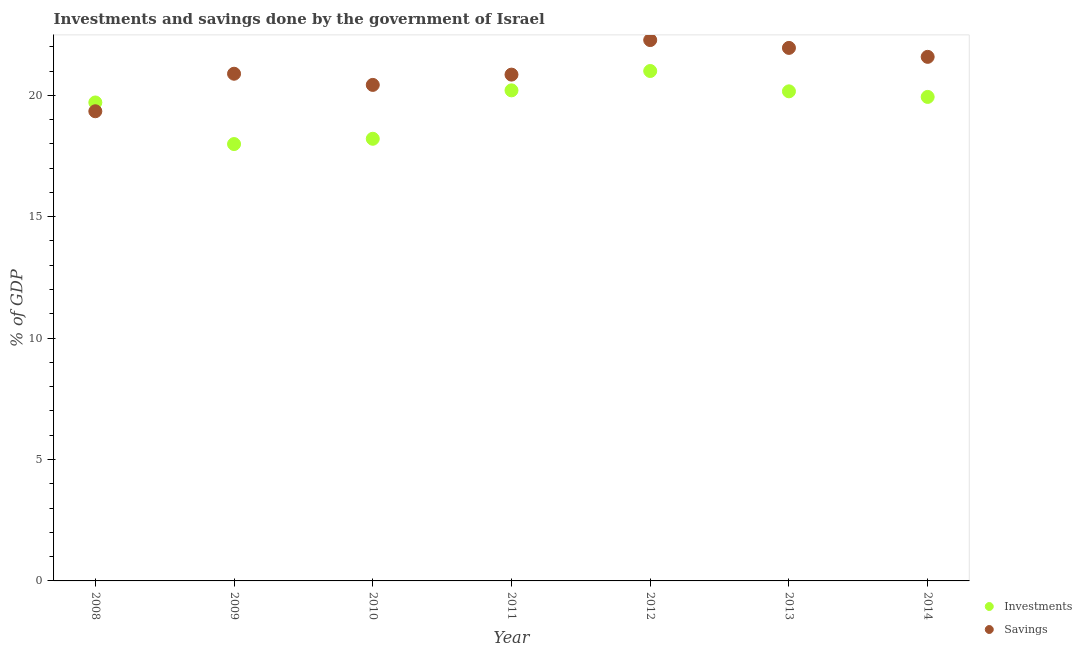How many different coloured dotlines are there?
Your answer should be compact. 2. Is the number of dotlines equal to the number of legend labels?
Give a very brief answer. Yes. What is the savings of government in 2013?
Keep it short and to the point. 21.95. Across all years, what is the maximum savings of government?
Ensure brevity in your answer.  22.27. Across all years, what is the minimum savings of government?
Your response must be concise. 19.34. In which year was the investments of government minimum?
Your answer should be very brief. 2009. What is the total investments of government in the graph?
Offer a terse response. 137.21. What is the difference between the investments of government in 2010 and that in 2011?
Offer a very short reply. -1.99. What is the difference between the investments of government in 2011 and the savings of government in 2009?
Offer a very short reply. -0.68. What is the average investments of government per year?
Your answer should be very brief. 19.6. In the year 2008, what is the difference between the investments of government and savings of government?
Your answer should be compact. 0.36. What is the ratio of the investments of government in 2013 to that in 2014?
Your response must be concise. 1.01. Is the difference between the savings of government in 2009 and 2012 greater than the difference between the investments of government in 2009 and 2012?
Give a very brief answer. Yes. What is the difference between the highest and the second highest savings of government?
Offer a terse response. 0.32. What is the difference between the highest and the lowest savings of government?
Keep it short and to the point. 2.93. Is the investments of government strictly greater than the savings of government over the years?
Offer a terse response. No. Is the savings of government strictly less than the investments of government over the years?
Keep it short and to the point. No. How many years are there in the graph?
Keep it short and to the point. 7. Does the graph contain any zero values?
Give a very brief answer. No. How many legend labels are there?
Your answer should be compact. 2. How are the legend labels stacked?
Make the answer very short. Vertical. What is the title of the graph?
Provide a succinct answer. Investments and savings done by the government of Israel. Does "Domestic liabilities" appear as one of the legend labels in the graph?
Ensure brevity in your answer.  No. What is the label or title of the Y-axis?
Provide a short and direct response. % of GDP. What is the % of GDP of Investments in 2008?
Your answer should be compact. 19.71. What is the % of GDP in Savings in 2008?
Your response must be concise. 19.34. What is the % of GDP in Investments in 2009?
Provide a short and direct response. 17.99. What is the % of GDP of Savings in 2009?
Offer a terse response. 20.89. What is the % of GDP of Investments in 2010?
Make the answer very short. 18.21. What is the % of GDP of Savings in 2010?
Offer a very short reply. 20.43. What is the % of GDP of Investments in 2011?
Your answer should be very brief. 20.2. What is the % of GDP of Savings in 2011?
Offer a very short reply. 20.85. What is the % of GDP of Investments in 2012?
Ensure brevity in your answer.  21. What is the % of GDP in Savings in 2012?
Offer a very short reply. 22.27. What is the % of GDP in Investments in 2013?
Your response must be concise. 20.16. What is the % of GDP in Savings in 2013?
Ensure brevity in your answer.  21.95. What is the % of GDP of Investments in 2014?
Offer a terse response. 19.93. What is the % of GDP of Savings in 2014?
Provide a succinct answer. 21.58. Across all years, what is the maximum % of GDP in Investments?
Offer a terse response. 21. Across all years, what is the maximum % of GDP of Savings?
Provide a succinct answer. 22.27. Across all years, what is the minimum % of GDP of Investments?
Your response must be concise. 17.99. Across all years, what is the minimum % of GDP of Savings?
Your response must be concise. 19.34. What is the total % of GDP of Investments in the graph?
Your response must be concise. 137.21. What is the total % of GDP in Savings in the graph?
Provide a short and direct response. 147.32. What is the difference between the % of GDP in Investments in 2008 and that in 2009?
Your answer should be very brief. 1.71. What is the difference between the % of GDP of Savings in 2008 and that in 2009?
Offer a terse response. -1.55. What is the difference between the % of GDP of Investments in 2008 and that in 2010?
Offer a terse response. 1.5. What is the difference between the % of GDP of Savings in 2008 and that in 2010?
Give a very brief answer. -1.09. What is the difference between the % of GDP in Investments in 2008 and that in 2011?
Your answer should be very brief. -0.5. What is the difference between the % of GDP of Savings in 2008 and that in 2011?
Your response must be concise. -1.51. What is the difference between the % of GDP of Investments in 2008 and that in 2012?
Your answer should be very brief. -1.3. What is the difference between the % of GDP in Savings in 2008 and that in 2012?
Offer a terse response. -2.93. What is the difference between the % of GDP of Investments in 2008 and that in 2013?
Make the answer very short. -0.46. What is the difference between the % of GDP of Savings in 2008 and that in 2013?
Offer a very short reply. -2.61. What is the difference between the % of GDP in Investments in 2008 and that in 2014?
Your response must be concise. -0.23. What is the difference between the % of GDP of Savings in 2008 and that in 2014?
Your answer should be compact. -2.24. What is the difference between the % of GDP of Investments in 2009 and that in 2010?
Your answer should be compact. -0.22. What is the difference between the % of GDP of Savings in 2009 and that in 2010?
Provide a succinct answer. 0.46. What is the difference between the % of GDP in Investments in 2009 and that in 2011?
Keep it short and to the point. -2.21. What is the difference between the % of GDP in Savings in 2009 and that in 2011?
Give a very brief answer. 0.04. What is the difference between the % of GDP in Investments in 2009 and that in 2012?
Ensure brevity in your answer.  -3.01. What is the difference between the % of GDP in Savings in 2009 and that in 2012?
Provide a succinct answer. -1.39. What is the difference between the % of GDP in Investments in 2009 and that in 2013?
Provide a succinct answer. -2.17. What is the difference between the % of GDP of Savings in 2009 and that in 2013?
Offer a terse response. -1.06. What is the difference between the % of GDP in Investments in 2009 and that in 2014?
Offer a terse response. -1.94. What is the difference between the % of GDP in Savings in 2009 and that in 2014?
Make the answer very short. -0.7. What is the difference between the % of GDP in Investments in 2010 and that in 2011?
Make the answer very short. -1.99. What is the difference between the % of GDP of Savings in 2010 and that in 2011?
Offer a very short reply. -0.42. What is the difference between the % of GDP of Investments in 2010 and that in 2012?
Your answer should be compact. -2.79. What is the difference between the % of GDP of Savings in 2010 and that in 2012?
Ensure brevity in your answer.  -1.85. What is the difference between the % of GDP in Investments in 2010 and that in 2013?
Your response must be concise. -1.95. What is the difference between the % of GDP in Savings in 2010 and that in 2013?
Make the answer very short. -1.52. What is the difference between the % of GDP in Investments in 2010 and that in 2014?
Your answer should be very brief. -1.72. What is the difference between the % of GDP of Savings in 2010 and that in 2014?
Provide a succinct answer. -1.16. What is the difference between the % of GDP of Investments in 2011 and that in 2012?
Your answer should be very brief. -0.8. What is the difference between the % of GDP of Savings in 2011 and that in 2012?
Provide a succinct answer. -1.42. What is the difference between the % of GDP of Investments in 2011 and that in 2013?
Give a very brief answer. 0.04. What is the difference between the % of GDP of Savings in 2011 and that in 2013?
Your response must be concise. -1.1. What is the difference between the % of GDP in Investments in 2011 and that in 2014?
Keep it short and to the point. 0.27. What is the difference between the % of GDP of Savings in 2011 and that in 2014?
Your answer should be very brief. -0.73. What is the difference between the % of GDP in Investments in 2012 and that in 2013?
Ensure brevity in your answer.  0.84. What is the difference between the % of GDP of Savings in 2012 and that in 2013?
Provide a short and direct response. 0.32. What is the difference between the % of GDP of Investments in 2012 and that in 2014?
Offer a very short reply. 1.07. What is the difference between the % of GDP in Savings in 2012 and that in 2014?
Provide a succinct answer. 0.69. What is the difference between the % of GDP of Investments in 2013 and that in 2014?
Give a very brief answer. 0.23. What is the difference between the % of GDP of Savings in 2013 and that in 2014?
Make the answer very short. 0.37. What is the difference between the % of GDP of Investments in 2008 and the % of GDP of Savings in 2009?
Offer a very short reply. -1.18. What is the difference between the % of GDP of Investments in 2008 and the % of GDP of Savings in 2010?
Make the answer very short. -0.72. What is the difference between the % of GDP of Investments in 2008 and the % of GDP of Savings in 2011?
Ensure brevity in your answer.  -1.15. What is the difference between the % of GDP in Investments in 2008 and the % of GDP in Savings in 2012?
Your answer should be compact. -2.57. What is the difference between the % of GDP in Investments in 2008 and the % of GDP in Savings in 2013?
Provide a short and direct response. -2.25. What is the difference between the % of GDP of Investments in 2008 and the % of GDP of Savings in 2014?
Make the answer very short. -1.88. What is the difference between the % of GDP in Investments in 2009 and the % of GDP in Savings in 2010?
Keep it short and to the point. -2.44. What is the difference between the % of GDP in Investments in 2009 and the % of GDP in Savings in 2011?
Provide a succinct answer. -2.86. What is the difference between the % of GDP of Investments in 2009 and the % of GDP of Savings in 2012?
Your response must be concise. -4.28. What is the difference between the % of GDP in Investments in 2009 and the % of GDP in Savings in 2013?
Your answer should be compact. -3.96. What is the difference between the % of GDP of Investments in 2009 and the % of GDP of Savings in 2014?
Provide a short and direct response. -3.59. What is the difference between the % of GDP of Investments in 2010 and the % of GDP of Savings in 2011?
Give a very brief answer. -2.64. What is the difference between the % of GDP in Investments in 2010 and the % of GDP in Savings in 2012?
Offer a terse response. -4.06. What is the difference between the % of GDP of Investments in 2010 and the % of GDP of Savings in 2013?
Your response must be concise. -3.74. What is the difference between the % of GDP of Investments in 2010 and the % of GDP of Savings in 2014?
Ensure brevity in your answer.  -3.37. What is the difference between the % of GDP of Investments in 2011 and the % of GDP of Savings in 2012?
Keep it short and to the point. -2.07. What is the difference between the % of GDP of Investments in 2011 and the % of GDP of Savings in 2013?
Make the answer very short. -1.75. What is the difference between the % of GDP of Investments in 2011 and the % of GDP of Savings in 2014?
Your answer should be compact. -1.38. What is the difference between the % of GDP of Investments in 2012 and the % of GDP of Savings in 2013?
Your answer should be compact. -0.95. What is the difference between the % of GDP in Investments in 2012 and the % of GDP in Savings in 2014?
Provide a short and direct response. -0.58. What is the difference between the % of GDP in Investments in 2013 and the % of GDP in Savings in 2014?
Your response must be concise. -1.42. What is the average % of GDP of Investments per year?
Give a very brief answer. 19.6. What is the average % of GDP of Savings per year?
Give a very brief answer. 21.05. In the year 2008, what is the difference between the % of GDP in Investments and % of GDP in Savings?
Offer a very short reply. 0.36. In the year 2009, what is the difference between the % of GDP in Investments and % of GDP in Savings?
Make the answer very short. -2.9. In the year 2010, what is the difference between the % of GDP in Investments and % of GDP in Savings?
Your answer should be very brief. -2.22. In the year 2011, what is the difference between the % of GDP of Investments and % of GDP of Savings?
Your answer should be compact. -0.65. In the year 2012, what is the difference between the % of GDP in Investments and % of GDP in Savings?
Make the answer very short. -1.27. In the year 2013, what is the difference between the % of GDP in Investments and % of GDP in Savings?
Offer a terse response. -1.79. In the year 2014, what is the difference between the % of GDP in Investments and % of GDP in Savings?
Keep it short and to the point. -1.65. What is the ratio of the % of GDP of Investments in 2008 to that in 2009?
Keep it short and to the point. 1.1. What is the ratio of the % of GDP in Savings in 2008 to that in 2009?
Make the answer very short. 0.93. What is the ratio of the % of GDP in Investments in 2008 to that in 2010?
Make the answer very short. 1.08. What is the ratio of the % of GDP of Savings in 2008 to that in 2010?
Give a very brief answer. 0.95. What is the ratio of the % of GDP in Investments in 2008 to that in 2011?
Your answer should be compact. 0.98. What is the ratio of the % of GDP of Savings in 2008 to that in 2011?
Make the answer very short. 0.93. What is the ratio of the % of GDP in Investments in 2008 to that in 2012?
Make the answer very short. 0.94. What is the ratio of the % of GDP in Savings in 2008 to that in 2012?
Keep it short and to the point. 0.87. What is the ratio of the % of GDP of Investments in 2008 to that in 2013?
Your answer should be compact. 0.98. What is the ratio of the % of GDP of Savings in 2008 to that in 2013?
Ensure brevity in your answer.  0.88. What is the ratio of the % of GDP of Savings in 2008 to that in 2014?
Give a very brief answer. 0.9. What is the ratio of the % of GDP in Savings in 2009 to that in 2010?
Make the answer very short. 1.02. What is the ratio of the % of GDP of Investments in 2009 to that in 2011?
Make the answer very short. 0.89. What is the ratio of the % of GDP in Investments in 2009 to that in 2012?
Your response must be concise. 0.86. What is the ratio of the % of GDP of Savings in 2009 to that in 2012?
Your response must be concise. 0.94. What is the ratio of the % of GDP of Investments in 2009 to that in 2013?
Your answer should be very brief. 0.89. What is the ratio of the % of GDP of Savings in 2009 to that in 2013?
Your response must be concise. 0.95. What is the ratio of the % of GDP in Investments in 2009 to that in 2014?
Keep it short and to the point. 0.9. What is the ratio of the % of GDP of Savings in 2009 to that in 2014?
Your answer should be very brief. 0.97. What is the ratio of the % of GDP in Investments in 2010 to that in 2011?
Your answer should be very brief. 0.9. What is the ratio of the % of GDP of Savings in 2010 to that in 2011?
Keep it short and to the point. 0.98. What is the ratio of the % of GDP in Investments in 2010 to that in 2012?
Offer a terse response. 0.87. What is the ratio of the % of GDP in Savings in 2010 to that in 2012?
Your answer should be compact. 0.92. What is the ratio of the % of GDP in Investments in 2010 to that in 2013?
Offer a very short reply. 0.9. What is the ratio of the % of GDP in Savings in 2010 to that in 2013?
Keep it short and to the point. 0.93. What is the ratio of the % of GDP of Investments in 2010 to that in 2014?
Your response must be concise. 0.91. What is the ratio of the % of GDP in Savings in 2010 to that in 2014?
Provide a short and direct response. 0.95. What is the ratio of the % of GDP in Savings in 2011 to that in 2012?
Offer a very short reply. 0.94. What is the ratio of the % of GDP of Investments in 2011 to that in 2013?
Provide a short and direct response. 1. What is the ratio of the % of GDP in Savings in 2011 to that in 2013?
Ensure brevity in your answer.  0.95. What is the ratio of the % of GDP of Investments in 2011 to that in 2014?
Keep it short and to the point. 1.01. What is the ratio of the % of GDP in Savings in 2011 to that in 2014?
Your response must be concise. 0.97. What is the ratio of the % of GDP of Investments in 2012 to that in 2013?
Make the answer very short. 1.04. What is the ratio of the % of GDP of Savings in 2012 to that in 2013?
Keep it short and to the point. 1.01. What is the ratio of the % of GDP in Investments in 2012 to that in 2014?
Offer a very short reply. 1.05. What is the ratio of the % of GDP in Savings in 2012 to that in 2014?
Provide a succinct answer. 1.03. What is the ratio of the % of GDP of Investments in 2013 to that in 2014?
Provide a succinct answer. 1.01. What is the ratio of the % of GDP in Savings in 2013 to that in 2014?
Ensure brevity in your answer.  1.02. What is the difference between the highest and the second highest % of GDP of Investments?
Ensure brevity in your answer.  0.8. What is the difference between the highest and the second highest % of GDP of Savings?
Provide a short and direct response. 0.32. What is the difference between the highest and the lowest % of GDP in Investments?
Make the answer very short. 3.01. What is the difference between the highest and the lowest % of GDP of Savings?
Offer a terse response. 2.93. 